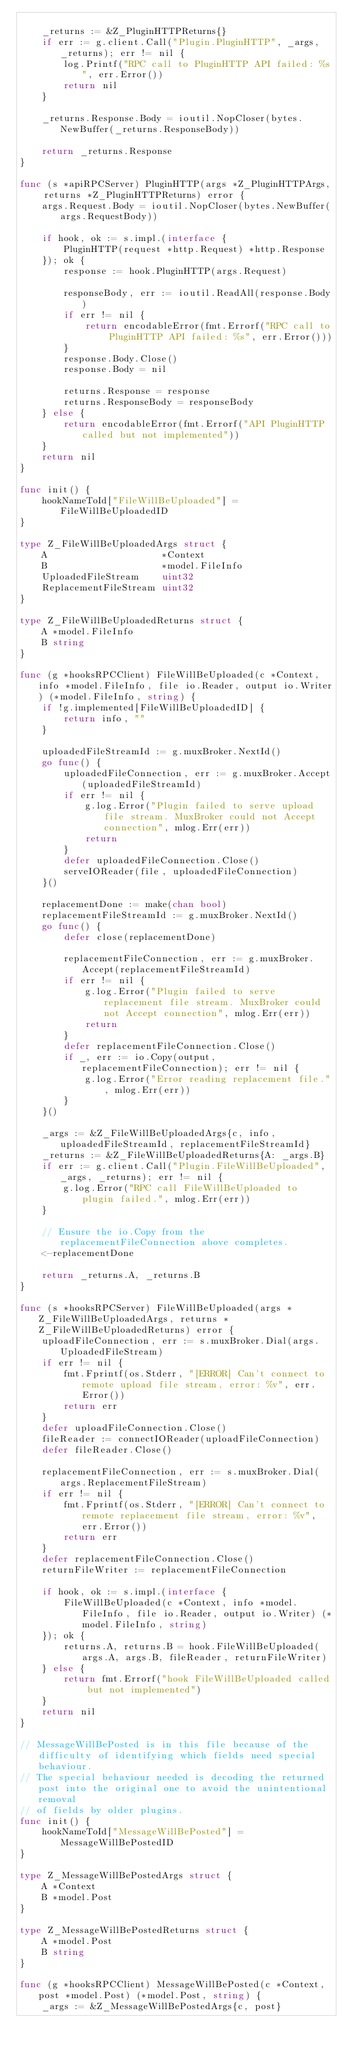<code> <loc_0><loc_0><loc_500><loc_500><_Go_>
	_returns := &Z_PluginHTTPReturns{}
	if err := g.client.Call("Plugin.PluginHTTP", _args, _returns); err != nil {
		log.Printf("RPC call to PluginHTTP API failed: %s", err.Error())
		return nil
	}

	_returns.Response.Body = ioutil.NopCloser(bytes.NewBuffer(_returns.ResponseBody))

	return _returns.Response
}

func (s *apiRPCServer) PluginHTTP(args *Z_PluginHTTPArgs, returns *Z_PluginHTTPReturns) error {
	args.Request.Body = ioutil.NopCloser(bytes.NewBuffer(args.RequestBody))

	if hook, ok := s.impl.(interface {
		PluginHTTP(request *http.Request) *http.Response
	}); ok {
		response := hook.PluginHTTP(args.Request)

		responseBody, err := ioutil.ReadAll(response.Body)
		if err != nil {
			return encodableError(fmt.Errorf("RPC call to PluginHTTP API failed: %s", err.Error()))
		}
		response.Body.Close()
		response.Body = nil

		returns.Response = response
		returns.ResponseBody = responseBody
	} else {
		return encodableError(fmt.Errorf("API PluginHTTP called but not implemented"))
	}
	return nil
}

func init() {
	hookNameToId["FileWillBeUploaded"] = FileWillBeUploadedID
}

type Z_FileWillBeUploadedArgs struct {
	A                     *Context
	B                     *model.FileInfo
	UploadedFileStream    uint32
	ReplacementFileStream uint32
}

type Z_FileWillBeUploadedReturns struct {
	A *model.FileInfo
	B string
}

func (g *hooksRPCClient) FileWillBeUploaded(c *Context, info *model.FileInfo, file io.Reader, output io.Writer) (*model.FileInfo, string) {
	if !g.implemented[FileWillBeUploadedID] {
		return info, ""
	}

	uploadedFileStreamId := g.muxBroker.NextId()
	go func() {
		uploadedFileConnection, err := g.muxBroker.Accept(uploadedFileStreamId)
		if err != nil {
			g.log.Error("Plugin failed to serve upload file stream. MuxBroker could not Accept connection", mlog.Err(err))
			return
		}
		defer uploadedFileConnection.Close()
		serveIOReader(file, uploadedFileConnection)
	}()

	replacementDone := make(chan bool)
	replacementFileStreamId := g.muxBroker.NextId()
	go func() {
		defer close(replacementDone)

		replacementFileConnection, err := g.muxBroker.Accept(replacementFileStreamId)
		if err != nil {
			g.log.Error("Plugin failed to serve replacement file stream. MuxBroker could not Accept connection", mlog.Err(err))
			return
		}
		defer replacementFileConnection.Close()
		if _, err := io.Copy(output, replacementFileConnection); err != nil {
			g.log.Error("Error reading replacement file.", mlog.Err(err))
		}
	}()

	_args := &Z_FileWillBeUploadedArgs{c, info, uploadedFileStreamId, replacementFileStreamId}
	_returns := &Z_FileWillBeUploadedReturns{A: _args.B}
	if err := g.client.Call("Plugin.FileWillBeUploaded", _args, _returns); err != nil {
		g.log.Error("RPC call FileWillBeUploaded to plugin failed.", mlog.Err(err))
	}

	// Ensure the io.Copy from the replacementFileConnection above completes.
	<-replacementDone

	return _returns.A, _returns.B
}

func (s *hooksRPCServer) FileWillBeUploaded(args *Z_FileWillBeUploadedArgs, returns *Z_FileWillBeUploadedReturns) error {
	uploadFileConnection, err := s.muxBroker.Dial(args.UploadedFileStream)
	if err != nil {
		fmt.Fprintf(os.Stderr, "[ERROR] Can't connect to remote upload file stream, error: %v", err.Error())
		return err
	}
	defer uploadFileConnection.Close()
	fileReader := connectIOReader(uploadFileConnection)
	defer fileReader.Close()

	replacementFileConnection, err := s.muxBroker.Dial(args.ReplacementFileStream)
	if err != nil {
		fmt.Fprintf(os.Stderr, "[ERROR] Can't connect to remote replacement file stream, error: %v", err.Error())
		return err
	}
	defer replacementFileConnection.Close()
	returnFileWriter := replacementFileConnection

	if hook, ok := s.impl.(interface {
		FileWillBeUploaded(c *Context, info *model.FileInfo, file io.Reader, output io.Writer) (*model.FileInfo, string)
	}); ok {
		returns.A, returns.B = hook.FileWillBeUploaded(args.A, args.B, fileReader, returnFileWriter)
	} else {
		return fmt.Errorf("hook FileWillBeUploaded called but not implemented")
	}
	return nil
}

// MessageWillBePosted is in this file because of the difficulty of identifying which fields need special behaviour.
// The special behaviour needed is decoding the returned post into the original one to avoid the unintentional removal
// of fields by older plugins.
func init() {
	hookNameToId["MessageWillBePosted"] = MessageWillBePostedID
}

type Z_MessageWillBePostedArgs struct {
	A *Context
	B *model.Post
}

type Z_MessageWillBePostedReturns struct {
	A *model.Post
	B string
}

func (g *hooksRPCClient) MessageWillBePosted(c *Context, post *model.Post) (*model.Post, string) {
	_args := &Z_MessageWillBePostedArgs{c, post}</code> 